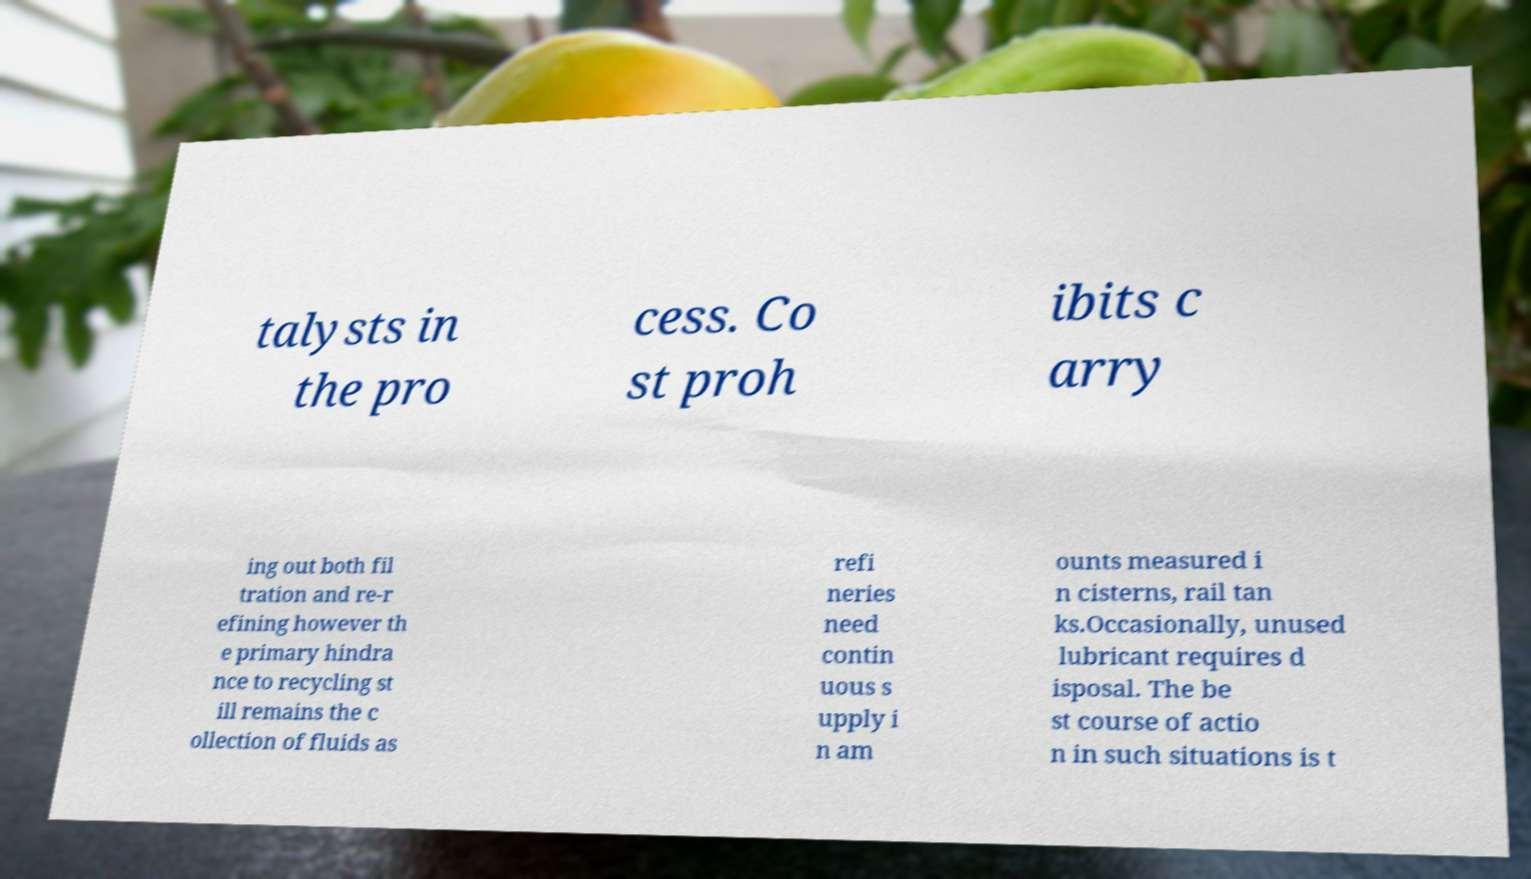I need the written content from this picture converted into text. Can you do that? talysts in the pro cess. Co st proh ibits c arry ing out both fil tration and re-r efining however th e primary hindra nce to recycling st ill remains the c ollection of fluids as refi neries need contin uous s upply i n am ounts measured i n cisterns, rail tan ks.Occasionally, unused lubricant requires d isposal. The be st course of actio n in such situations is t 